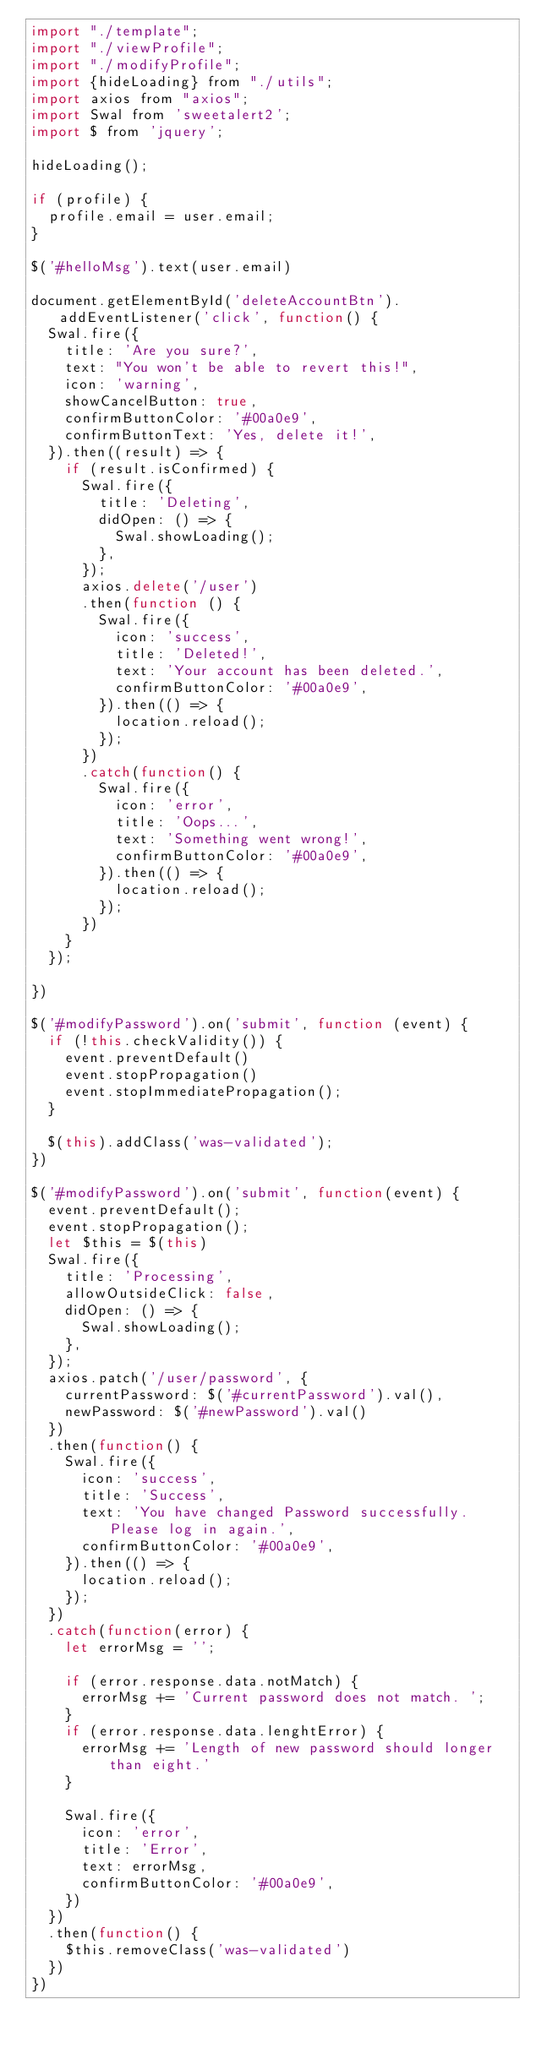<code> <loc_0><loc_0><loc_500><loc_500><_JavaScript_>import "./template";
import "./viewProfile";
import "./modifyProfile";
import {hideLoading} from "./utils";
import axios from "axios";
import Swal from 'sweetalert2';
import $ from 'jquery';

hideLoading();

if (profile) {
  profile.email = user.email;
}

$('#helloMsg').text(user.email)

document.getElementById('deleteAccountBtn').addEventListener('click', function() {
  Swal.fire({
    title: 'Are you sure?',
    text: "You won't be able to revert this!",
    icon: 'warning',
    showCancelButton: true,
    confirmButtonColor: '#00a0e9',
    confirmButtonText: 'Yes, delete it!',
  }).then((result) => {
    if (result.isConfirmed) {
      Swal.fire({
        title: 'Deleting',
        didOpen: () => {
          Swal.showLoading();
        },
      });
      axios.delete('/user')
      .then(function () {
        Swal.fire({
          icon: 'success',
          title: 'Deleted!',
          text: 'Your account has been deleted.',
          confirmButtonColor: '#00a0e9',
        }).then(() => {
          location.reload();
        });
      })
      .catch(function() {
        Swal.fire({
          icon: 'error',
          title: 'Oops...',
          text: 'Something went wrong!',
          confirmButtonColor: '#00a0e9',
        }).then(() => {
          location.reload();
        });
      })
    }
  });
  
})

$('#modifyPassword').on('submit', function (event) {
  if (!this.checkValidity()) {
    event.preventDefault()
    event.stopPropagation()
    event.stopImmediatePropagation();
  }

  $(this).addClass('was-validated');
})

$('#modifyPassword').on('submit', function(event) {
  event.preventDefault();
  event.stopPropagation();
  let $this = $(this)
  Swal.fire({
    title: 'Processing',
    allowOutsideClick: false,
    didOpen: () => {
      Swal.showLoading();
    },
  });
  axios.patch('/user/password', {
    currentPassword: $('#currentPassword').val(),
    newPassword: $('#newPassword').val()
  })
  .then(function() {
    Swal.fire({
      icon: 'success',
      title: 'Success',
      text: 'You have changed Password successfully. Please log in again.',
      confirmButtonColor: '#00a0e9',
    }).then(() => {
      location.reload();
    });
  })
  .catch(function(error) {
    let errorMsg = '';

    if (error.response.data.notMatch) {
      errorMsg += 'Current password does not match. ';
    }
    if (error.response.data.lenghtError) {
      errorMsg += 'Length of new password should longer than eight.'
    }

    Swal.fire({
      icon: 'error',
      title: 'Error',
      text: errorMsg,
      confirmButtonColor: '#00a0e9',
    })
  })
  .then(function() {
    $this.removeClass('was-validated')
  })
})
</code> 